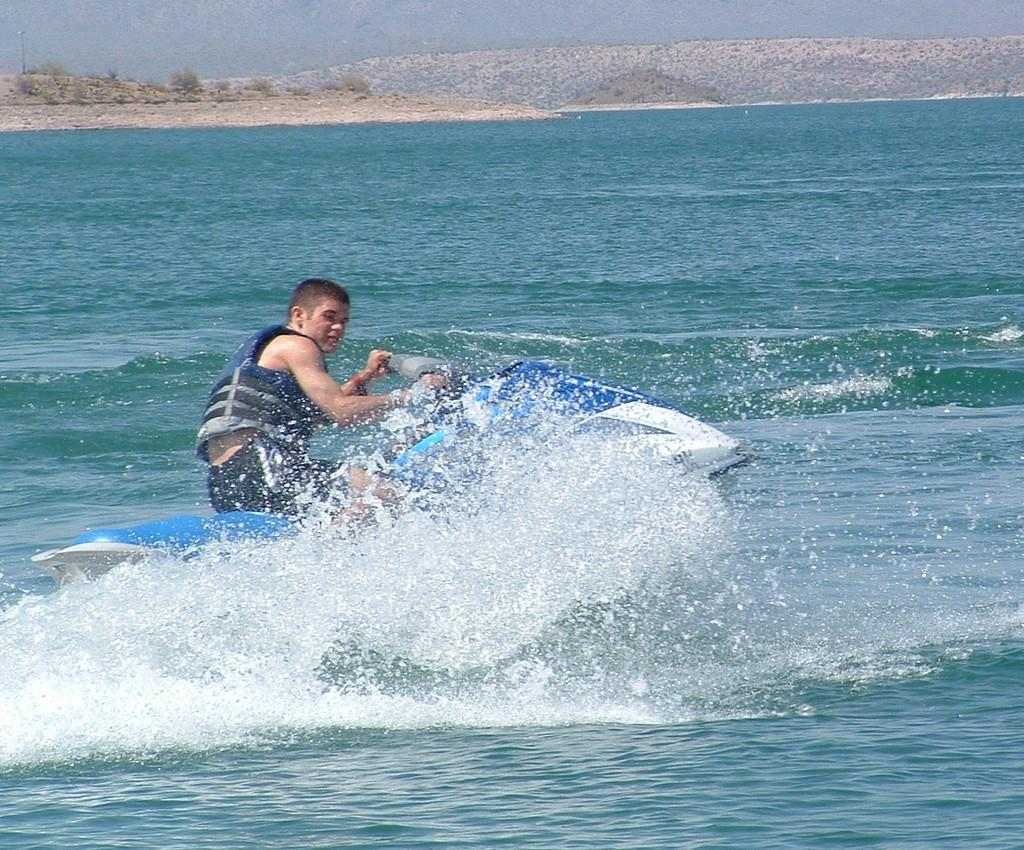Who is in the image? There is a person in the image. What is the person wearing? The person is wearing a life jacket. What is the person doing in the image? The person is driving a speed boat. Can you describe the speed boat? The speed boat is blue and white in color. What can be seen in the background of the image? There are mountains and water visible in the background of the image. What language is the person speaking to their sister in the image? There is no mention of a sister or any conversation in the image, so it is impossible to determine the language being spoken. 